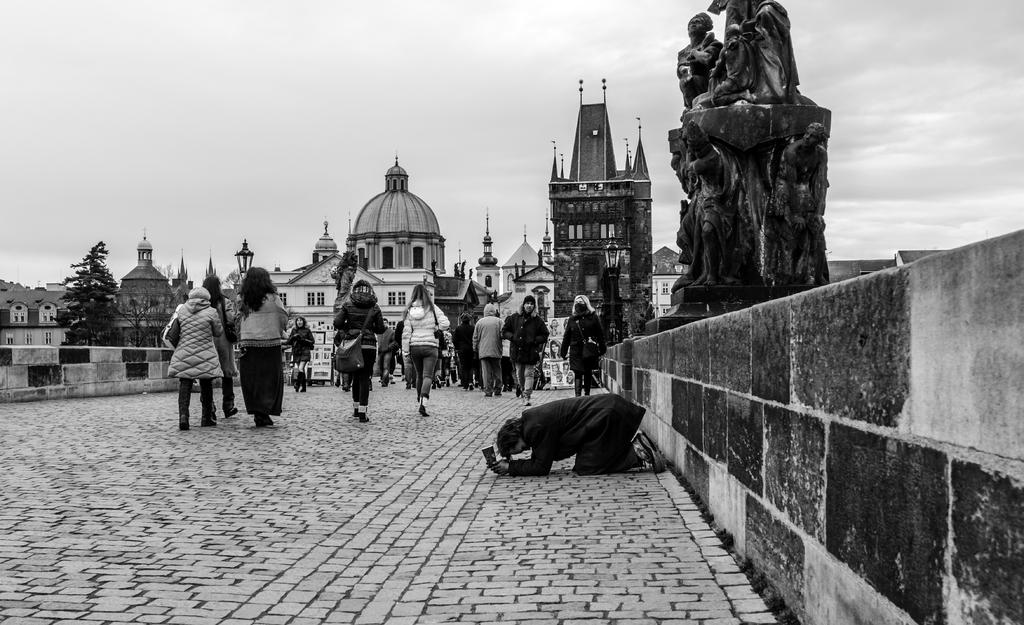What type of structures can be seen in the image? There are buildings in the image. What are the people in the image doing? There are persons walking on the street in the image. What part of the natural environment is visible in the image? Trees are visible in the image. What is visible in the background of the image? Sky is visible in the image. What architectural feature can be seen in the image? There is a wall in the image. What type of account can be seen in the image? There is no account visible in the image. What scent is associated with the trees in the image? The image does not provide information about the scent of the trees. 